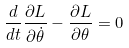<formula> <loc_0><loc_0><loc_500><loc_500>\frac { d } { d t } \frac { \partial L } { \partial \dot { \theta } } - \frac { \partial L } { \partial \theta } = 0</formula> 